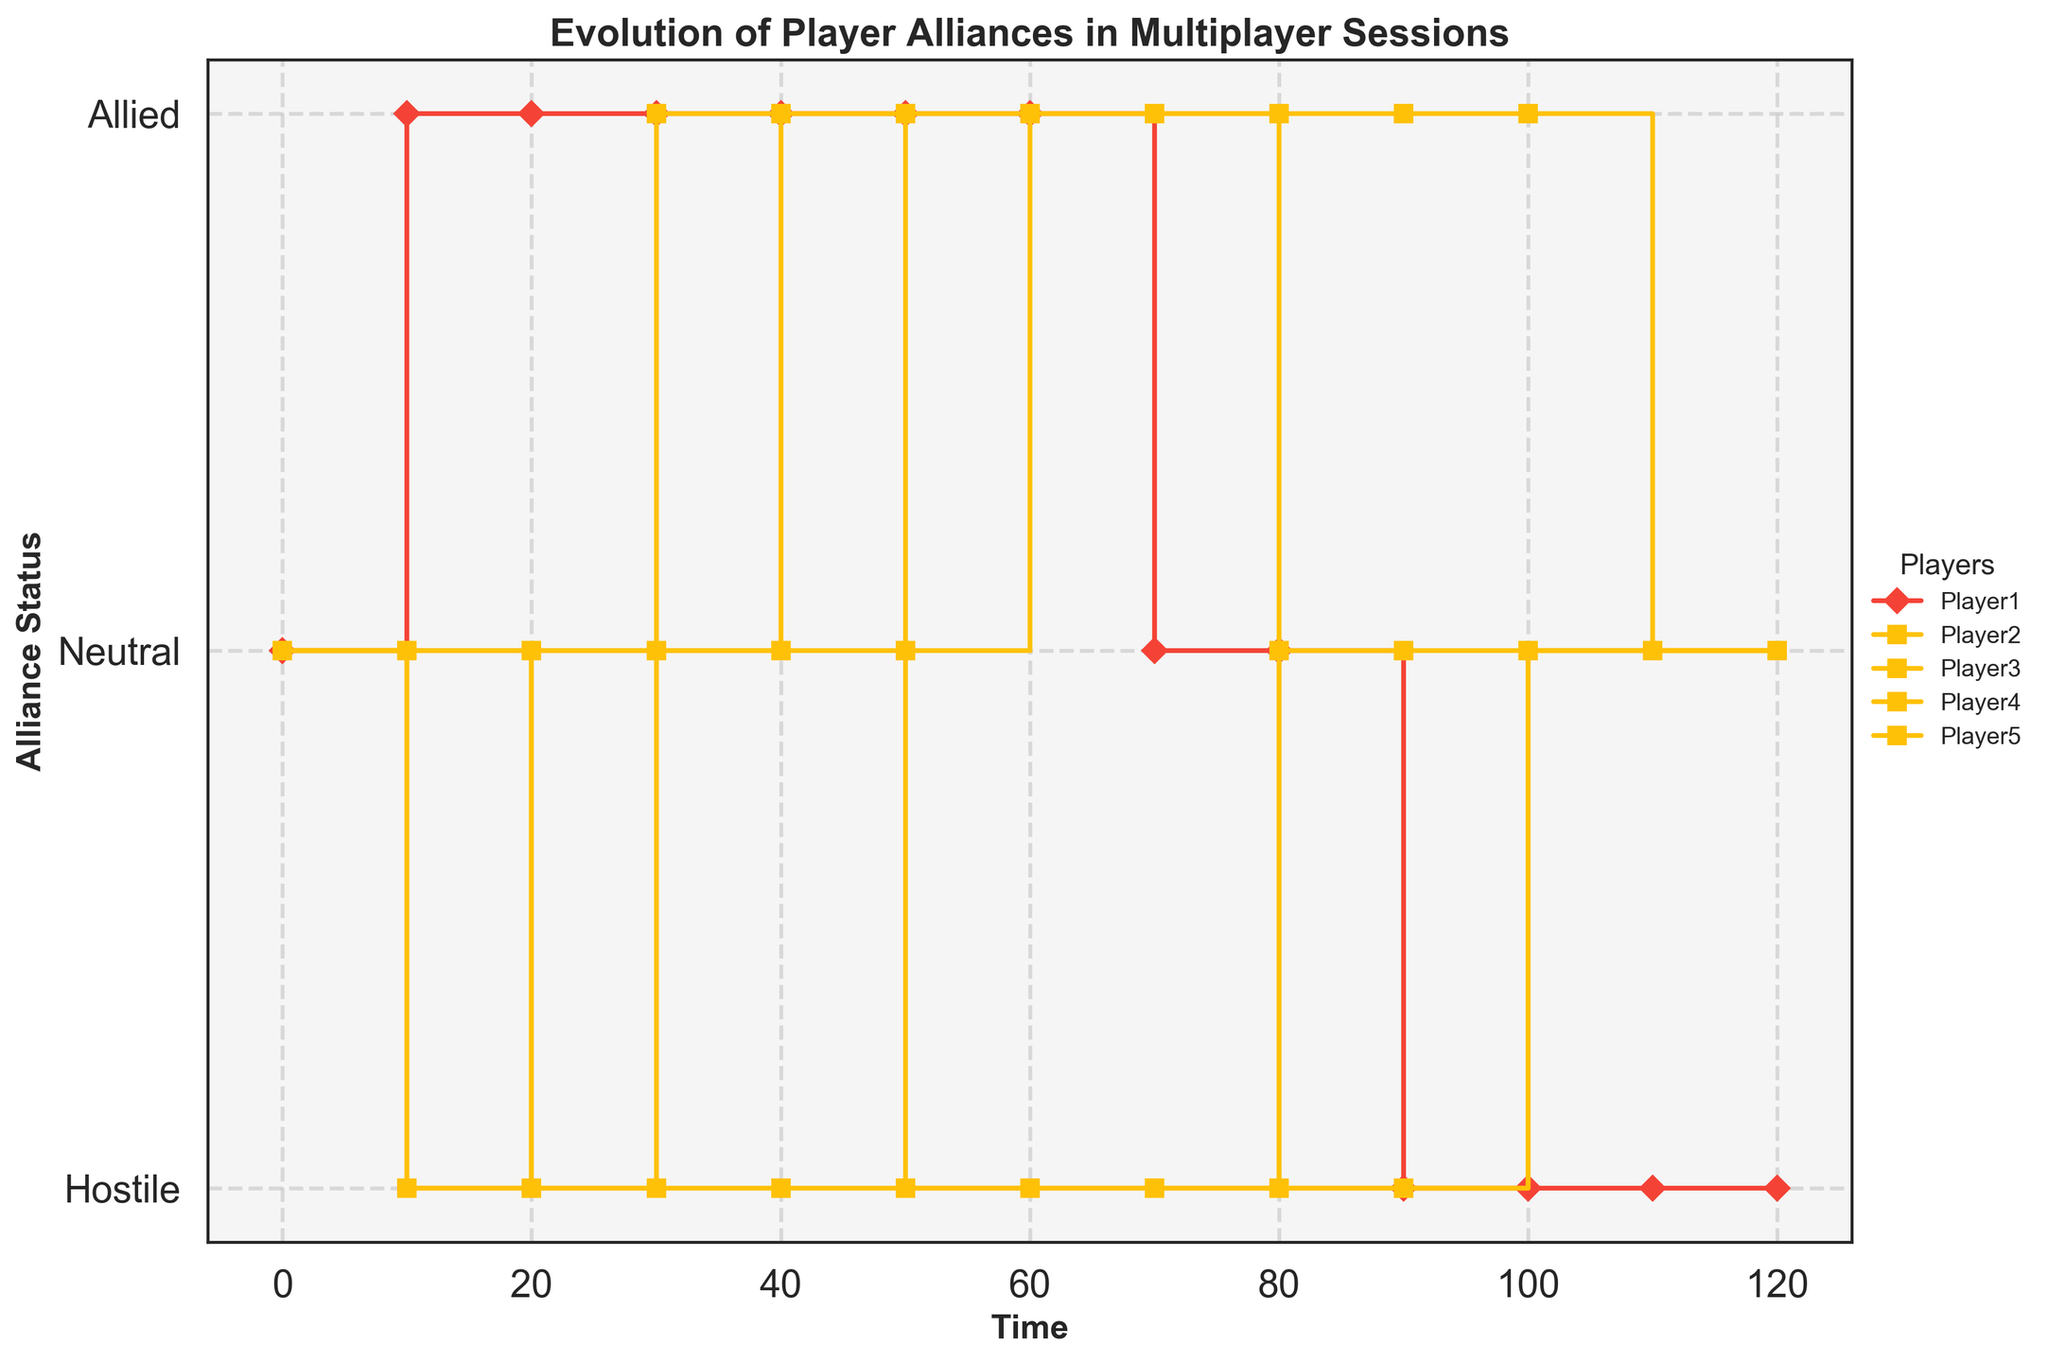What is the title of the figure? The title is usually found at the top of the figure in bold and larger font.
Answer: Evolution of Player Alliances in Multiplayer Sessions What are the labels on the y-axis? The y-axis labels can be seen on the side of the plot, indicating the alliance status levels.
Answer: Hostile, Neutral, Allied At what time did Player 3 change from Hostile to Neutral? Look for the transition in the step plot line representing Player 3's status.
Answer: 30 Which players were Allied at time 50? Check the horizontal lines near the 'Allied' level at time 50.
Answer: Player 1, Player 5 How many players ended as Neutral by time 120? Count the lines at the 'Neutral' level at the last time point (120).
Answer: 1 Which player had the most changes in alliance status? Observe the number of steps or changes in the plot line for each player.
Answer: Player 3 How long did Player 2 remain Hostile? Locate the duration where Player 2's line stays in the 'Hostile' region.
Answer: 10 to 120 (110 units of time) What was the alliance status of Player 4 at time 70? Read the y-coordinate value of Player 4's line at time 70.
Answer: Hostile Which player started as Neutral and ended as Hostile at the final time point? Look for a player starting at 'Neutral' at time 0 and ending at 'Hostile' at time 120.
Answer: Player 1 